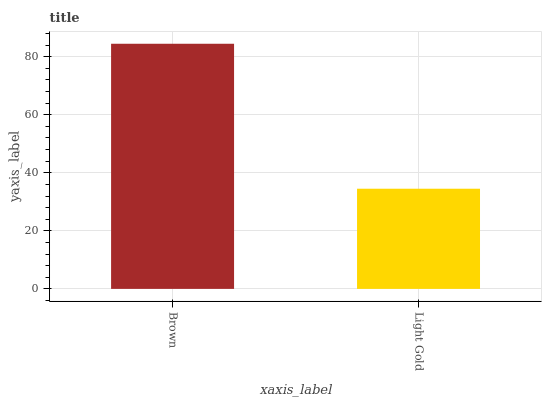Is Light Gold the maximum?
Answer yes or no. No. Is Brown greater than Light Gold?
Answer yes or no. Yes. Is Light Gold less than Brown?
Answer yes or no. Yes. Is Light Gold greater than Brown?
Answer yes or no. No. Is Brown less than Light Gold?
Answer yes or no. No. Is Brown the high median?
Answer yes or no. Yes. Is Light Gold the low median?
Answer yes or no. Yes. Is Light Gold the high median?
Answer yes or no. No. Is Brown the low median?
Answer yes or no. No. 